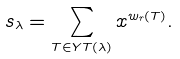Convert formula to latex. <formula><loc_0><loc_0><loc_500><loc_500>s _ { \lambda } = \sum _ { T \in Y T ( \lambda ) } x ^ { w _ { r } ( T ) } .</formula> 